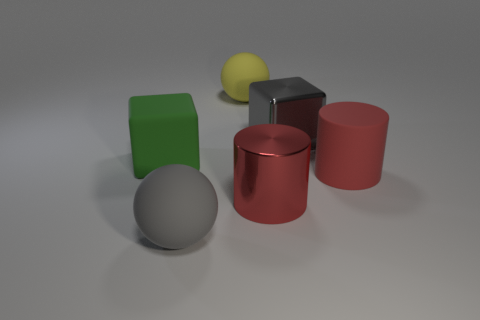How many red cylinders must be subtracted to get 1 red cylinders? 1 Add 2 large matte things. How many objects exist? 8 Subtract all balls. How many objects are left? 4 Subtract 0 brown cylinders. How many objects are left? 6 Subtract all large gray metallic objects. Subtract all red cylinders. How many objects are left? 3 Add 5 matte blocks. How many matte blocks are left? 6 Add 1 rubber spheres. How many rubber spheres exist? 3 